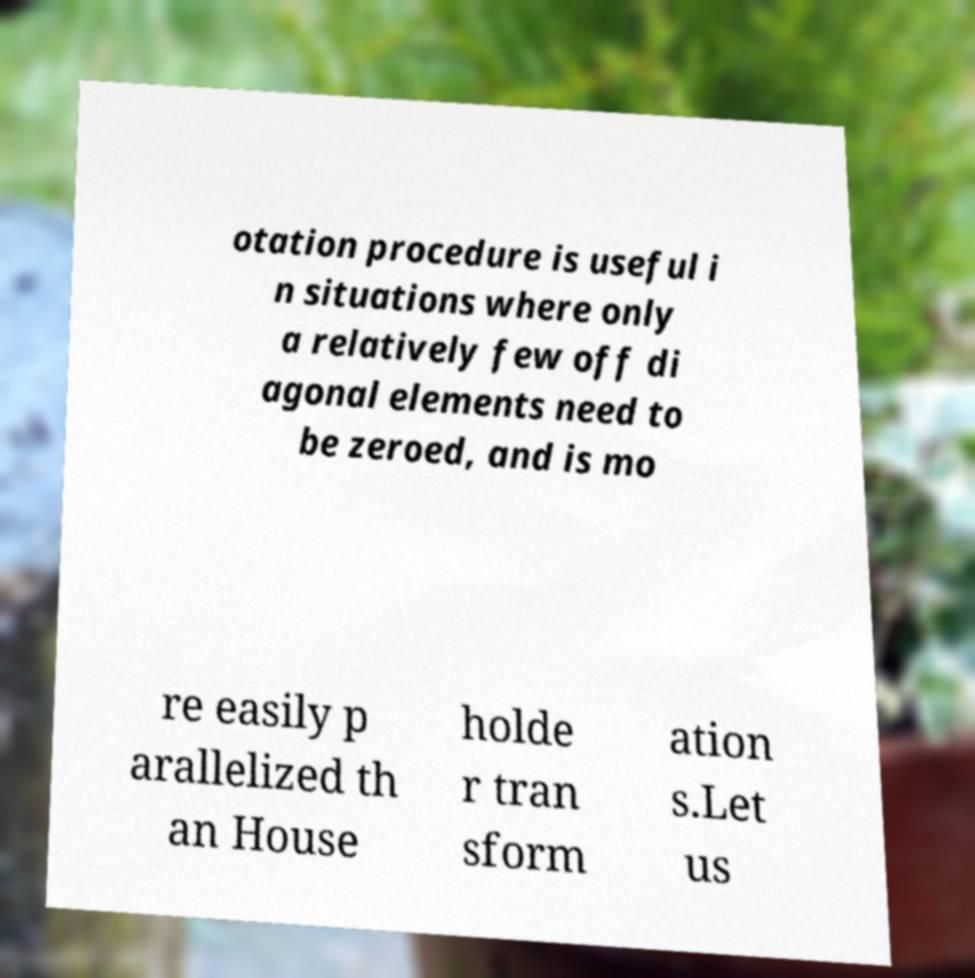Please identify and transcribe the text found in this image. otation procedure is useful i n situations where only a relatively few off di agonal elements need to be zeroed, and is mo re easily p arallelized th an House holde r tran sform ation s.Let us 